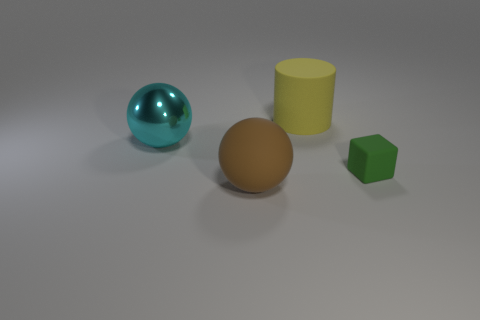Are there any other things that have the same shape as the tiny green object?
Make the answer very short. No. Are there an equal number of yellow cylinders that are in front of the large brown object and gray metal cylinders?
Provide a succinct answer. Yes. How many things are both in front of the large matte cylinder and right of the metallic sphere?
Keep it short and to the point. 2. What is the size of the matte thing that is the same shape as the cyan metal object?
Your response must be concise. Large. How many big brown balls are made of the same material as the cylinder?
Offer a very short reply. 1. Are there fewer large yellow cylinders in front of the yellow matte cylinder than tiny green matte cylinders?
Offer a very short reply. No. How many small metallic blocks are there?
Your answer should be compact. 0. Do the cyan object and the small green thing have the same shape?
Ensure brevity in your answer.  No. What size is the matte thing behind the rubber thing to the right of the matte cylinder?
Your response must be concise. Large. Is there a brown matte object that has the same size as the cyan object?
Offer a very short reply. Yes. 